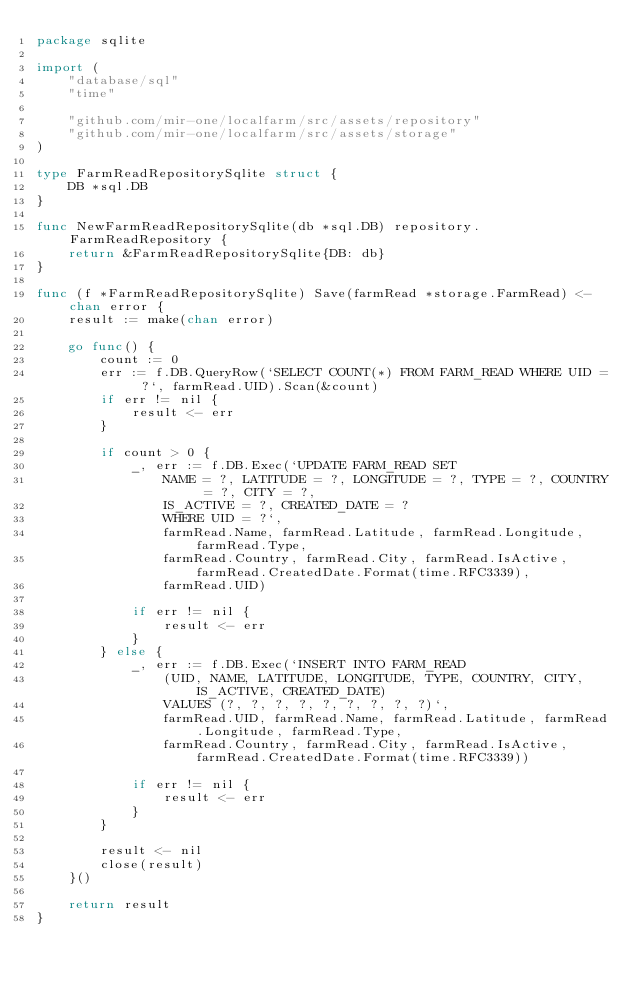<code> <loc_0><loc_0><loc_500><loc_500><_Go_>package sqlite

import (
	"database/sql"
	"time"

	"github.com/mir-one/localfarm/src/assets/repository"
	"github.com/mir-one/localfarm/src/assets/storage"
)

type FarmReadRepositorySqlite struct {
	DB *sql.DB
}

func NewFarmReadRepositorySqlite(db *sql.DB) repository.FarmReadRepository {
	return &FarmReadRepositorySqlite{DB: db}
}

func (f *FarmReadRepositorySqlite) Save(farmRead *storage.FarmRead) <-chan error {
	result := make(chan error)

	go func() {
		count := 0
		err := f.DB.QueryRow(`SELECT COUNT(*) FROM FARM_READ WHERE UID = ?`, farmRead.UID).Scan(&count)
		if err != nil {
			result <- err
		}

		if count > 0 {
			_, err := f.DB.Exec(`UPDATE FARM_READ SET
				NAME = ?, LATITUDE = ?, LONGITUDE = ?, TYPE = ?, COUNTRY = ?, CITY = ?,
				IS_ACTIVE = ?, CREATED_DATE = ?
				WHERE UID = ?`,
				farmRead.Name, farmRead.Latitude, farmRead.Longitude, farmRead.Type,
				farmRead.Country, farmRead.City, farmRead.IsActive, farmRead.CreatedDate.Format(time.RFC3339),
				farmRead.UID)

			if err != nil {
				result <- err
			}
		} else {
			_, err := f.DB.Exec(`INSERT INTO FARM_READ
				(UID, NAME, LATITUDE, LONGITUDE, TYPE, COUNTRY, CITY, IS_ACTIVE, CREATED_DATE)
				VALUES (?, ?, ?, ?, ?, ?, ?, ?, ?)`,
				farmRead.UID, farmRead.Name, farmRead.Latitude, farmRead.Longitude, farmRead.Type,
				farmRead.Country, farmRead.City, farmRead.IsActive, farmRead.CreatedDate.Format(time.RFC3339))

			if err != nil {
				result <- err
			}
		}

		result <- nil
		close(result)
	}()

	return result
}
</code> 